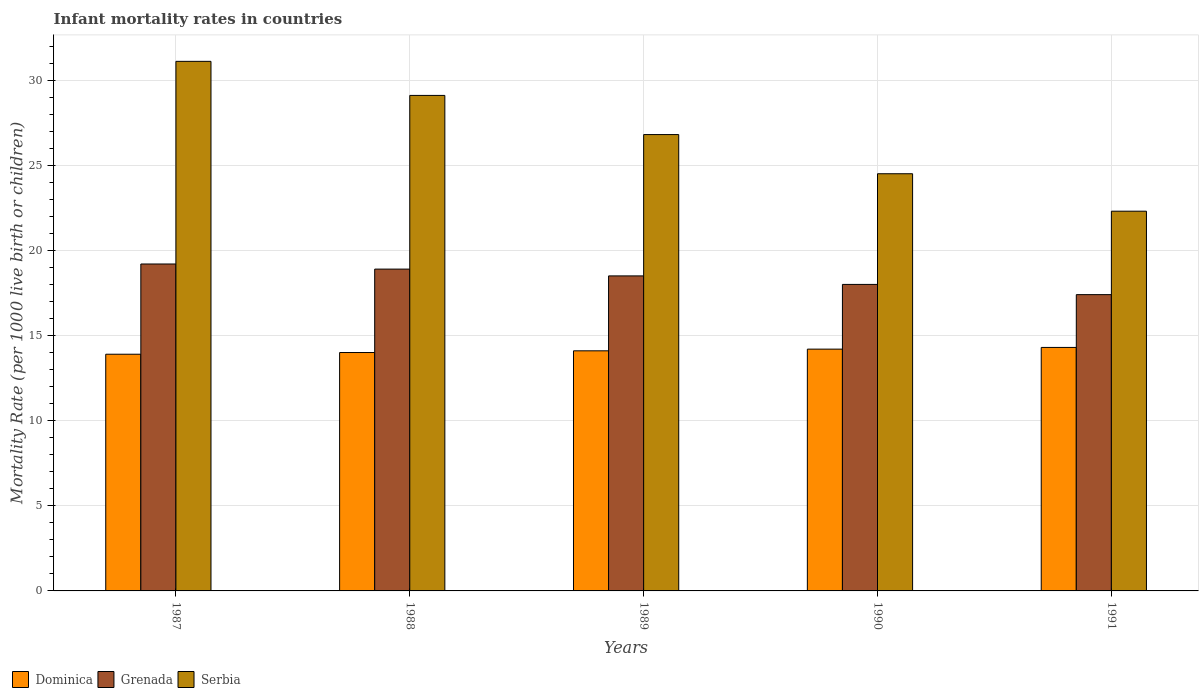Are the number of bars per tick equal to the number of legend labels?
Provide a succinct answer. Yes. Are the number of bars on each tick of the X-axis equal?
Your answer should be compact. Yes. How many bars are there on the 5th tick from the left?
Ensure brevity in your answer.  3. How many bars are there on the 3rd tick from the right?
Provide a short and direct response. 3. What is the label of the 1st group of bars from the left?
Keep it short and to the point. 1987. In how many cases, is the number of bars for a given year not equal to the number of legend labels?
Offer a very short reply. 0. In which year was the infant mortality rate in Dominica minimum?
Provide a short and direct response. 1987. What is the total infant mortality rate in Serbia in the graph?
Give a very brief answer. 133.8. What is the difference between the infant mortality rate in Dominica in 1990 and that in 1991?
Your answer should be compact. -0.1. What is the difference between the infant mortality rate in Dominica in 1989 and the infant mortality rate in Serbia in 1991?
Offer a very short reply. -8.2. In the year 1987, what is the difference between the infant mortality rate in Dominica and infant mortality rate in Serbia?
Your answer should be very brief. -17.2. In how many years, is the infant mortality rate in Dominica greater than 25?
Make the answer very short. 0. What is the ratio of the infant mortality rate in Serbia in 1987 to that in 1989?
Offer a terse response. 1.16. What is the difference between the highest and the lowest infant mortality rate in Dominica?
Provide a succinct answer. 0.4. Is the sum of the infant mortality rate in Serbia in 1990 and 1991 greater than the maximum infant mortality rate in Grenada across all years?
Offer a terse response. Yes. What does the 2nd bar from the left in 1988 represents?
Your answer should be very brief. Grenada. What does the 2nd bar from the right in 1990 represents?
Provide a short and direct response. Grenada. How many bars are there?
Your answer should be very brief. 15. Are all the bars in the graph horizontal?
Offer a terse response. No. How many years are there in the graph?
Your answer should be compact. 5. What is the difference between two consecutive major ticks on the Y-axis?
Your answer should be very brief. 5. Are the values on the major ticks of Y-axis written in scientific E-notation?
Offer a very short reply. No. Does the graph contain grids?
Provide a succinct answer. Yes. How many legend labels are there?
Your answer should be very brief. 3. How are the legend labels stacked?
Ensure brevity in your answer.  Horizontal. What is the title of the graph?
Make the answer very short. Infant mortality rates in countries. Does "Solomon Islands" appear as one of the legend labels in the graph?
Your answer should be compact. No. What is the label or title of the X-axis?
Ensure brevity in your answer.  Years. What is the label or title of the Y-axis?
Make the answer very short. Mortality Rate (per 1000 live birth or children). What is the Mortality Rate (per 1000 live birth or children) of Dominica in 1987?
Keep it short and to the point. 13.9. What is the Mortality Rate (per 1000 live birth or children) of Grenada in 1987?
Make the answer very short. 19.2. What is the Mortality Rate (per 1000 live birth or children) of Serbia in 1987?
Your answer should be very brief. 31.1. What is the Mortality Rate (per 1000 live birth or children) of Serbia in 1988?
Make the answer very short. 29.1. What is the Mortality Rate (per 1000 live birth or children) of Dominica in 1989?
Your answer should be compact. 14.1. What is the Mortality Rate (per 1000 live birth or children) in Serbia in 1989?
Provide a short and direct response. 26.8. What is the Mortality Rate (per 1000 live birth or children) of Dominica in 1990?
Your answer should be very brief. 14.2. What is the Mortality Rate (per 1000 live birth or children) in Serbia in 1991?
Your answer should be very brief. 22.3. Across all years, what is the maximum Mortality Rate (per 1000 live birth or children) of Dominica?
Provide a short and direct response. 14.3. Across all years, what is the maximum Mortality Rate (per 1000 live birth or children) in Serbia?
Offer a terse response. 31.1. Across all years, what is the minimum Mortality Rate (per 1000 live birth or children) in Grenada?
Give a very brief answer. 17.4. Across all years, what is the minimum Mortality Rate (per 1000 live birth or children) in Serbia?
Offer a terse response. 22.3. What is the total Mortality Rate (per 1000 live birth or children) in Dominica in the graph?
Provide a succinct answer. 70.5. What is the total Mortality Rate (per 1000 live birth or children) in Grenada in the graph?
Offer a terse response. 92. What is the total Mortality Rate (per 1000 live birth or children) in Serbia in the graph?
Your answer should be very brief. 133.8. What is the difference between the Mortality Rate (per 1000 live birth or children) of Dominica in 1987 and that in 1988?
Your response must be concise. -0.1. What is the difference between the Mortality Rate (per 1000 live birth or children) in Serbia in 1987 and that in 1988?
Keep it short and to the point. 2. What is the difference between the Mortality Rate (per 1000 live birth or children) of Grenada in 1987 and that in 1989?
Keep it short and to the point. 0.7. What is the difference between the Mortality Rate (per 1000 live birth or children) in Dominica in 1987 and that in 1990?
Your answer should be very brief. -0.3. What is the difference between the Mortality Rate (per 1000 live birth or children) in Grenada in 1987 and that in 1990?
Offer a very short reply. 1.2. What is the difference between the Mortality Rate (per 1000 live birth or children) of Dominica in 1988 and that in 1989?
Offer a very short reply. -0.1. What is the difference between the Mortality Rate (per 1000 live birth or children) in Grenada in 1988 and that in 1989?
Your response must be concise. 0.4. What is the difference between the Mortality Rate (per 1000 live birth or children) in Dominica in 1988 and that in 1990?
Offer a very short reply. -0.2. What is the difference between the Mortality Rate (per 1000 live birth or children) of Dominica in 1988 and that in 1991?
Offer a terse response. -0.3. What is the difference between the Mortality Rate (per 1000 live birth or children) in Grenada in 1989 and that in 1990?
Your response must be concise. 0.5. What is the difference between the Mortality Rate (per 1000 live birth or children) in Dominica in 1989 and that in 1991?
Offer a very short reply. -0.2. What is the difference between the Mortality Rate (per 1000 live birth or children) in Grenada in 1990 and that in 1991?
Give a very brief answer. 0.6. What is the difference between the Mortality Rate (per 1000 live birth or children) of Dominica in 1987 and the Mortality Rate (per 1000 live birth or children) of Grenada in 1988?
Keep it short and to the point. -5. What is the difference between the Mortality Rate (per 1000 live birth or children) in Dominica in 1987 and the Mortality Rate (per 1000 live birth or children) in Serbia in 1988?
Offer a terse response. -15.2. What is the difference between the Mortality Rate (per 1000 live birth or children) in Grenada in 1987 and the Mortality Rate (per 1000 live birth or children) in Serbia in 1988?
Make the answer very short. -9.9. What is the difference between the Mortality Rate (per 1000 live birth or children) of Dominica in 1987 and the Mortality Rate (per 1000 live birth or children) of Serbia in 1989?
Keep it short and to the point. -12.9. What is the difference between the Mortality Rate (per 1000 live birth or children) of Grenada in 1987 and the Mortality Rate (per 1000 live birth or children) of Serbia in 1989?
Provide a short and direct response. -7.6. What is the difference between the Mortality Rate (per 1000 live birth or children) in Dominica in 1987 and the Mortality Rate (per 1000 live birth or children) in Grenada in 1991?
Give a very brief answer. -3.5. What is the difference between the Mortality Rate (per 1000 live birth or children) of Dominica in 1987 and the Mortality Rate (per 1000 live birth or children) of Serbia in 1991?
Your answer should be very brief. -8.4. What is the difference between the Mortality Rate (per 1000 live birth or children) of Grenada in 1987 and the Mortality Rate (per 1000 live birth or children) of Serbia in 1991?
Offer a terse response. -3.1. What is the difference between the Mortality Rate (per 1000 live birth or children) in Dominica in 1988 and the Mortality Rate (per 1000 live birth or children) in Grenada in 1989?
Provide a short and direct response. -4.5. What is the difference between the Mortality Rate (per 1000 live birth or children) of Grenada in 1988 and the Mortality Rate (per 1000 live birth or children) of Serbia in 1990?
Keep it short and to the point. -5.6. What is the difference between the Mortality Rate (per 1000 live birth or children) in Dominica in 1988 and the Mortality Rate (per 1000 live birth or children) in Grenada in 1991?
Offer a very short reply. -3.4. What is the difference between the Mortality Rate (per 1000 live birth or children) in Grenada in 1988 and the Mortality Rate (per 1000 live birth or children) in Serbia in 1991?
Your answer should be compact. -3.4. What is the difference between the Mortality Rate (per 1000 live birth or children) in Dominica in 1989 and the Mortality Rate (per 1000 live birth or children) in Grenada in 1990?
Provide a short and direct response. -3.9. What is the difference between the Mortality Rate (per 1000 live birth or children) in Dominica in 1989 and the Mortality Rate (per 1000 live birth or children) in Serbia in 1990?
Your answer should be compact. -10.4. What is the difference between the Mortality Rate (per 1000 live birth or children) of Grenada in 1989 and the Mortality Rate (per 1000 live birth or children) of Serbia in 1990?
Offer a very short reply. -6. What is the difference between the Mortality Rate (per 1000 live birth or children) in Dominica in 1989 and the Mortality Rate (per 1000 live birth or children) in Grenada in 1991?
Offer a terse response. -3.3. What is the difference between the Mortality Rate (per 1000 live birth or children) of Dominica in 1989 and the Mortality Rate (per 1000 live birth or children) of Serbia in 1991?
Ensure brevity in your answer.  -8.2. What is the difference between the Mortality Rate (per 1000 live birth or children) in Grenada in 1989 and the Mortality Rate (per 1000 live birth or children) in Serbia in 1991?
Ensure brevity in your answer.  -3.8. What is the difference between the Mortality Rate (per 1000 live birth or children) in Dominica in 1990 and the Mortality Rate (per 1000 live birth or children) in Serbia in 1991?
Offer a very short reply. -8.1. What is the difference between the Mortality Rate (per 1000 live birth or children) of Grenada in 1990 and the Mortality Rate (per 1000 live birth or children) of Serbia in 1991?
Give a very brief answer. -4.3. What is the average Mortality Rate (per 1000 live birth or children) in Dominica per year?
Provide a short and direct response. 14.1. What is the average Mortality Rate (per 1000 live birth or children) in Grenada per year?
Offer a terse response. 18.4. What is the average Mortality Rate (per 1000 live birth or children) in Serbia per year?
Offer a very short reply. 26.76. In the year 1987, what is the difference between the Mortality Rate (per 1000 live birth or children) of Dominica and Mortality Rate (per 1000 live birth or children) of Grenada?
Ensure brevity in your answer.  -5.3. In the year 1987, what is the difference between the Mortality Rate (per 1000 live birth or children) in Dominica and Mortality Rate (per 1000 live birth or children) in Serbia?
Provide a short and direct response. -17.2. In the year 1988, what is the difference between the Mortality Rate (per 1000 live birth or children) of Dominica and Mortality Rate (per 1000 live birth or children) of Grenada?
Offer a very short reply. -4.9. In the year 1988, what is the difference between the Mortality Rate (per 1000 live birth or children) in Dominica and Mortality Rate (per 1000 live birth or children) in Serbia?
Provide a short and direct response. -15.1. In the year 1988, what is the difference between the Mortality Rate (per 1000 live birth or children) of Grenada and Mortality Rate (per 1000 live birth or children) of Serbia?
Make the answer very short. -10.2. In the year 1989, what is the difference between the Mortality Rate (per 1000 live birth or children) in Dominica and Mortality Rate (per 1000 live birth or children) in Grenada?
Ensure brevity in your answer.  -4.4. In the year 1989, what is the difference between the Mortality Rate (per 1000 live birth or children) in Dominica and Mortality Rate (per 1000 live birth or children) in Serbia?
Give a very brief answer. -12.7. In the year 1989, what is the difference between the Mortality Rate (per 1000 live birth or children) in Grenada and Mortality Rate (per 1000 live birth or children) in Serbia?
Keep it short and to the point. -8.3. In the year 1991, what is the difference between the Mortality Rate (per 1000 live birth or children) in Dominica and Mortality Rate (per 1000 live birth or children) in Grenada?
Keep it short and to the point. -3.1. In the year 1991, what is the difference between the Mortality Rate (per 1000 live birth or children) of Dominica and Mortality Rate (per 1000 live birth or children) of Serbia?
Ensure brevity in your answer.  -8. In the year 1991, what is the difference between the Mortality Rate (per 1000 live birth or children) of Grenada and Mortality Rate (per 1000 live birth or children) of Serbia?
Ensure brevity in your answer.  -4.9. What is the ratio of the Mortality Rate (per 1000 live birth or children) of Dominica in 1987 to that in 1988?
Provide a short and direct response. 0.99. What is the ratio of the Mortality Rate (per 1000 live birth or children) in Grenada in 1987 to that in 1988?
Provide a succinct answer. 1.02. What is the ratio of the Mortality Rate (per 1000 live birth or children) of Serbia in 1987 to that in 1988?
Offer a terse response. 1.07. What is the ratio of the Mortality Rate (per 1000 live birth or children) of Dominica in 1987 to that in 1989?
Provide a succinct answer. 0.99. What is the ratio of the Mortality Rate (per 1000 live birth or children) of Grenada in 1987 to that in 1989?
Your response must be concise. 1.04. What is the ratio of the Mortality Rate (per 1000 live birth or children) in Serbia in 1987 to that in 1989?
Keep it short and to the point. 1.16. What is the ratio of the Mortality Rate (per 1000 live birth or children) in Dominica in 1987 to that in 1990?
Your response must be concise. 0.98. What is the ratio of the Mortality Rate (per 1000 live birth or children) in Grenada in 1987 to that in 1990?
Offer a very short reply. 1.07. What is the ratio of the Mortality Rate (per 1000 live birth or children) in Serbia in 1987 to that in 1990?
Offer a very short reply. 1.27. What is the ratio of the Mortality Rate (per 1000 live birth or children) in Grenada in 1987 to that in 1991?
Your response must be concise. 1.1. What is the ratio of the Mortality Rate (per 1000 live birth or children) of Serbia in 1987 to that in 1991?
Your response must be concise. 1.39. What is the ratio of the Mortality Rate (per 1000 live birth or children) of Grenada in 1988 to that in 1989?
Your answer should be compact. 1.02. What is the ratio of the Mortality Rate (per 1000 live birth or children) in Serbia in 1988 to that in 1989?
Provide a succinct answer. 1.09. What is the ratio of the Mortality Rate (per 1000 live birth or children) in Dominica in 1988 to that in 1990?
Your answer should be very brief. 0.99. What is the ratio of the Mortality Rate (per 1000 live birth or children) of Serbia in 1988 to that in 1990?
Your response must be concise. 1.19. What is the ratio of the Mortality Rate (per 1000 live birth or children) of Grenada in 1988 to that in 1991?
Give a very brief answer. 1.09. What is the ratio of the Mortality Rate (per 1000 live birth or children) of Serbia in 1988 to that in 1991?
Ensure brevity in your answer.  1.3. What is the ratio of the Mortality Rate (per 1000 live birth or children) of Dominica in 1989 to that in 1990?
Provide a succinct answer. 0.99. What is the ratio of the Mortality Rate (per 1000 live birth or children) of Grenada in 1989 to that in 1990?
Provide a short and direct response. 1.03. What is the ratio of the Mortality Rate (per 1000 live birth or children) of Serbia in 1989 to that in 1990?
Offer a very short reply. 1.09. What is the ratio of the Mortality Rate (per 1000 live birth or children) of Dominica in 1989 to that in 1991?
Provide a succinct answer. 0.99. What is the ratio of the Mortality Rate (per 1000 live birth or children) in Grenada in 1989 to that in 1991?
Provide a short and direct response. 1.06. What is the ratio of the Mortality Rate (per 1000 live birth or children) of Serbia in 1989 to that in 1991?
Your answer should be compact. 1.2. What is the ratio of the Mortality Rate (per 1000 live birth or children) in Grenada in 1990 to that in 1991?
Give a very brief answer. 1.03. What is the ratio of the Mortality Rate (per 1000 live birth or children) of Serbia in 1990 to that in 1991?
Make the answer very short. 1.1. What is the difference between the highest and the second highest Mortality Rate (per 1000 live birth or children) in Grenada?
Offer a terse response. 0.3. What is the difference between the highest and the second highest Mortality Rate (per 1000 live birth or children) in Serbia?
Your answer should be very brief. 2. What is the difference between the highest and the lowest Mortality Rate (per 1000 live birth or children) of Dominica?
Give a very brief answer. 0.4. What is the difference between the highest and the lowest Mortality Rate (per 1000 live birth or children) in Grenada?
Ensure brevity in your answer.  1.8. 